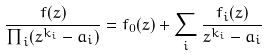<formula> <loc_0><loc_0><loc_500><loc_500>\frac { f ( z ) } { \prod _ { i } ( z ^ { k _ { i } } - a _ { i } ) } = f _ { 0 } ( z ) + \sum _ { i } \frac { f _ { i } ( z ) } { z ^ { k _ { i } } - a _ { i } }</formula> 